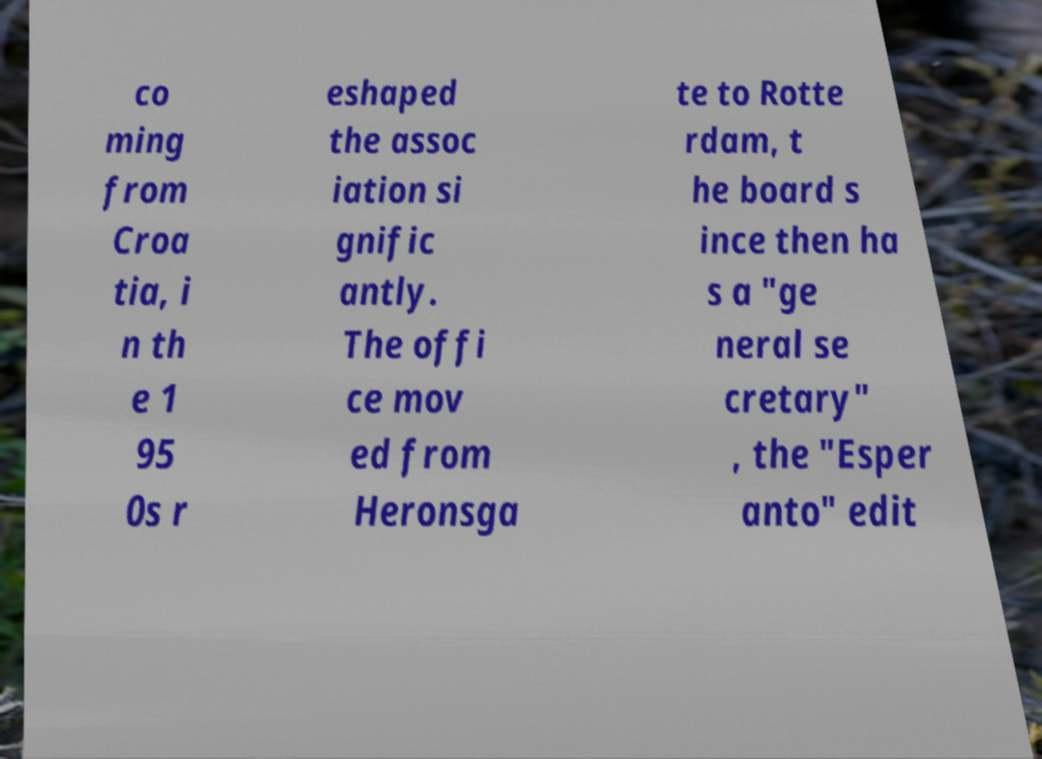Can you read and provide the text displayed in the image?This photo seems to have some interesting text. Can you extract and type it out for me? co ming from Croa tia, i n th e 1 95 0s r eshaped the assoc iation si gnific antly. The offi ce mov ed from Heronsga te to Rotte rdam, t he board s ince then ha s a "ge neral se cretary" , the "Esper anto" edit 